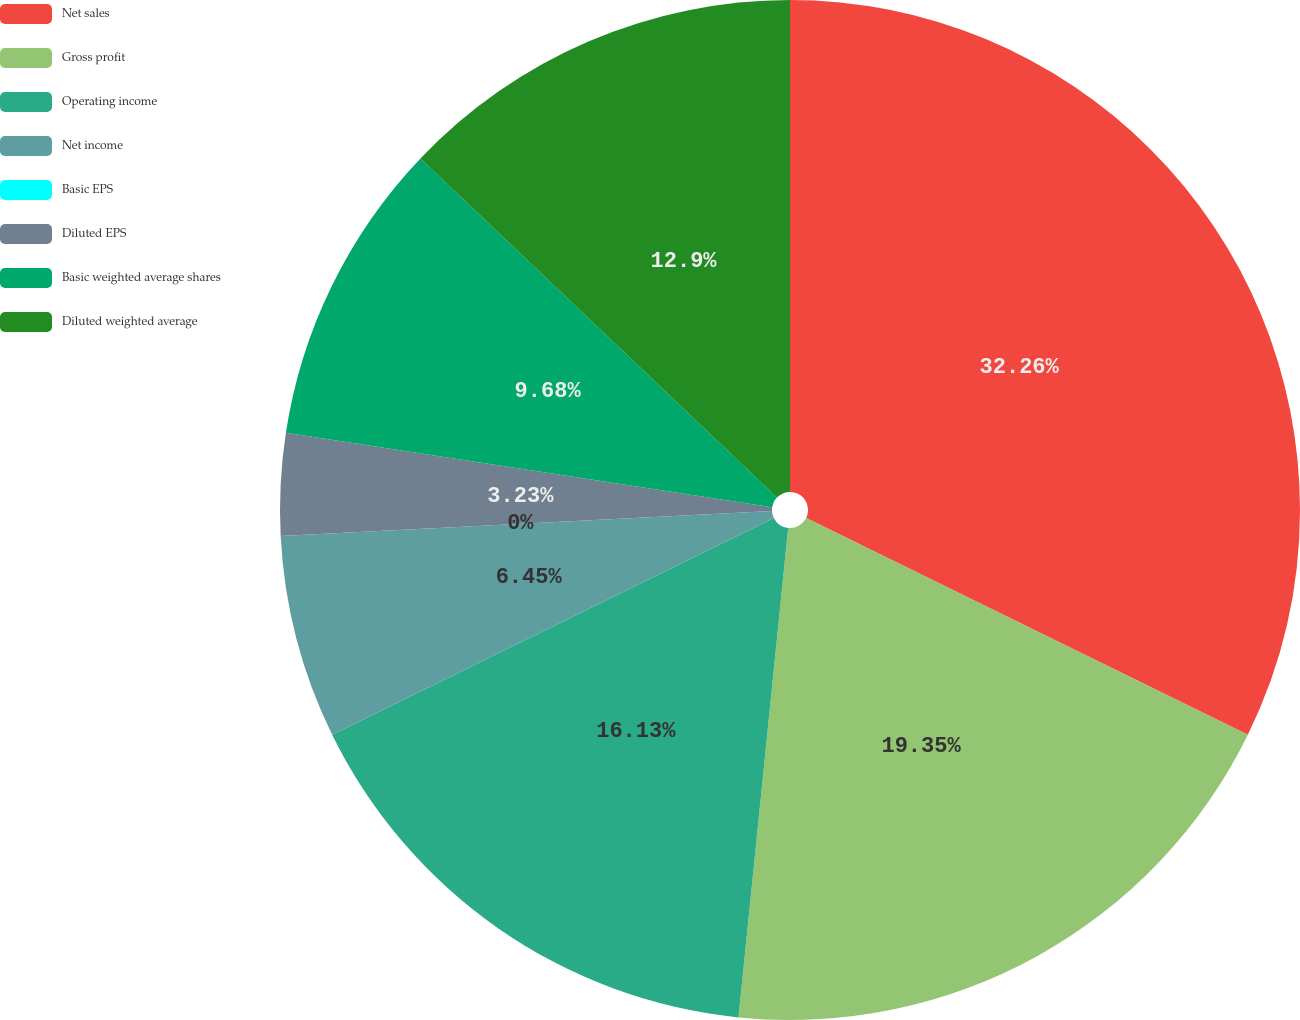<chart> <loc_0><loc_0><loc_500><loc_500><pie_chart><fcel>Net sales<fcel>Gross profit<fcel>Operating income<fcel>Net income<fcel>Basic EPS<fcel>Diluted EPS<fcel>Basic weighted average shares<fcel>Diluted weighted average<nl><fcel>32.26%<fcel>19.35%<fcel>16.13%<fcel>6.45%<fcel>0.0%<fcel>3.23%<fcel>9.68%<fcel>12.9%<nl></chart> 